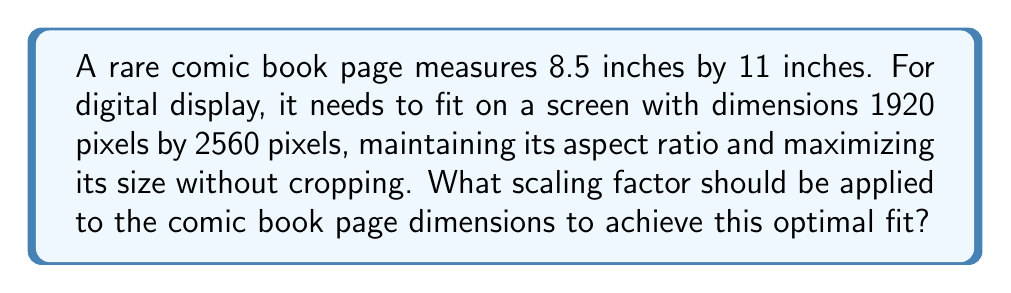Help me with this question. Let's approach this step-by-step:

1) First, we need to calculate the aspect ratios of both the comic book page and the digital screen.

   Comic book aspect ratio: $\frac{8.5}{11} \approx 0.7727$
   Screen aspect ratio: $\frac{1920}{2560} = 0.75$

2) Since the aspect ratios are different, we need to fit the comic book page to the screen's dimensions while maintaining its original aspect ratio. We'll do this by fitting it to either the width or height of the screen, whichever is limiting.

3) Let's calculate two potential scaling factors:
   
   Width scaling factor: $\frac{1920}{8.5} \approx 225.8824$
   Height scaling factor: $\frac{2560}{11} \approx 232.7273$

4) To avoid cropping, we need to use the smaller of these two scaling factors. In this case, it's the width scaling factor.

5) Therefore, the optimal scaling factor is approximately 225.8824.

6) To verify:
   New width: $8.5 \times 225.8824 = 1920$ pixels
   New height: $11 \times 225.8824 = 2484.7064$ pixels

   This fits within the 1920x2560 screen without cropping and maintains the original aspect ratio.
Answer: $225.8824$ 